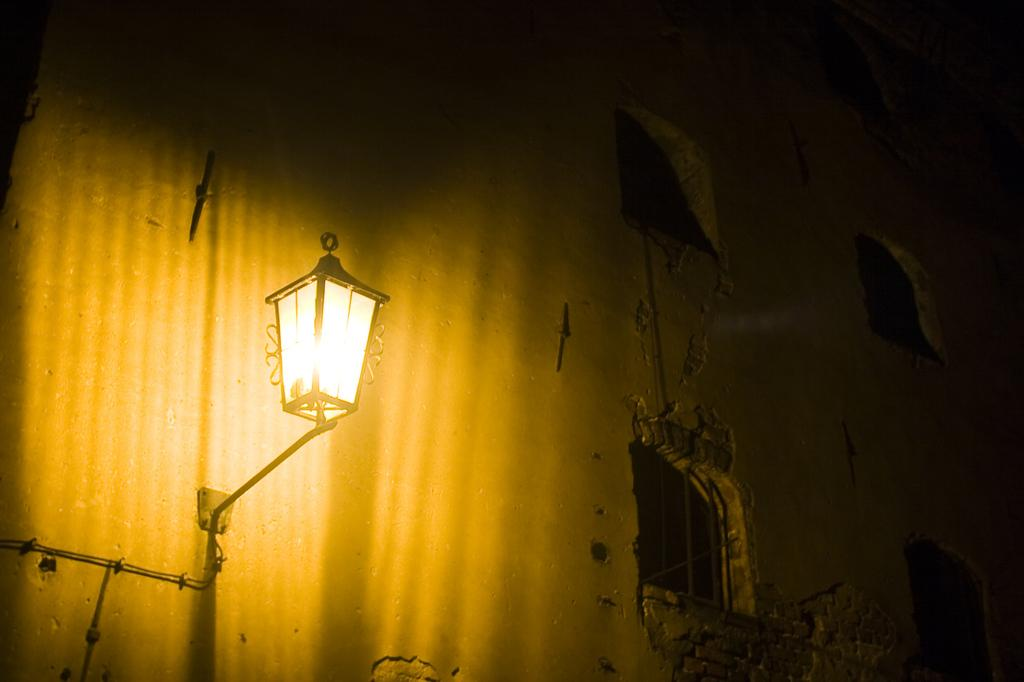What is the main subject of the picture? The main subject of the picture is a building. What specific features can be observed on the building? The building has windows. Can you describe any other elements in the picture? There is a light visible in the picture. What type of cork can be seen on the building in the image? There is no cork present on the building in the image. What suggestion is being made by the box in the image? There is no box present in the image, so no suggestion can be made. 